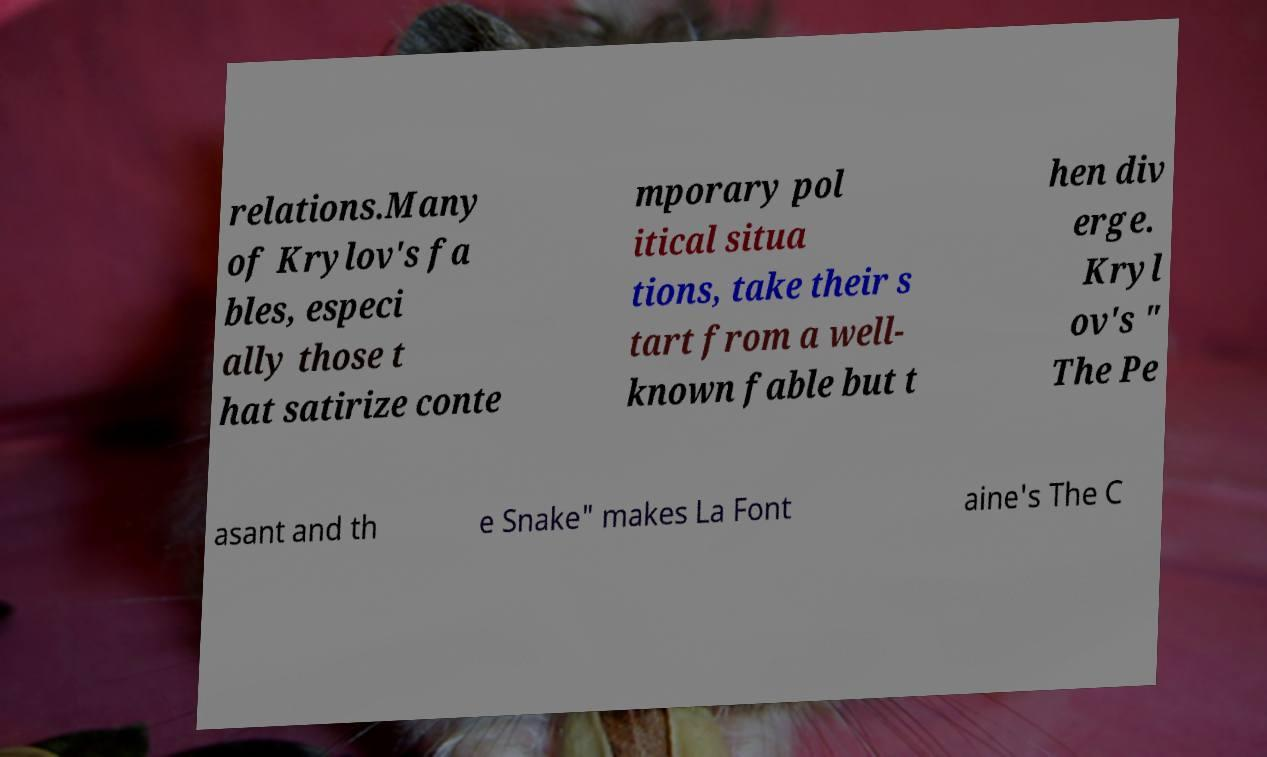For documentation purposes, I need the text within this image transcribed. Could you provide that? relations.Many of Krylov's fa bles, especi ally those t hat satirize conte mporary pol itical situa tions, take their s tart from a well- known fable but t hen div erge. Kryl ov's " The Pe asant and th e Snake" makes La Font aine's The C 